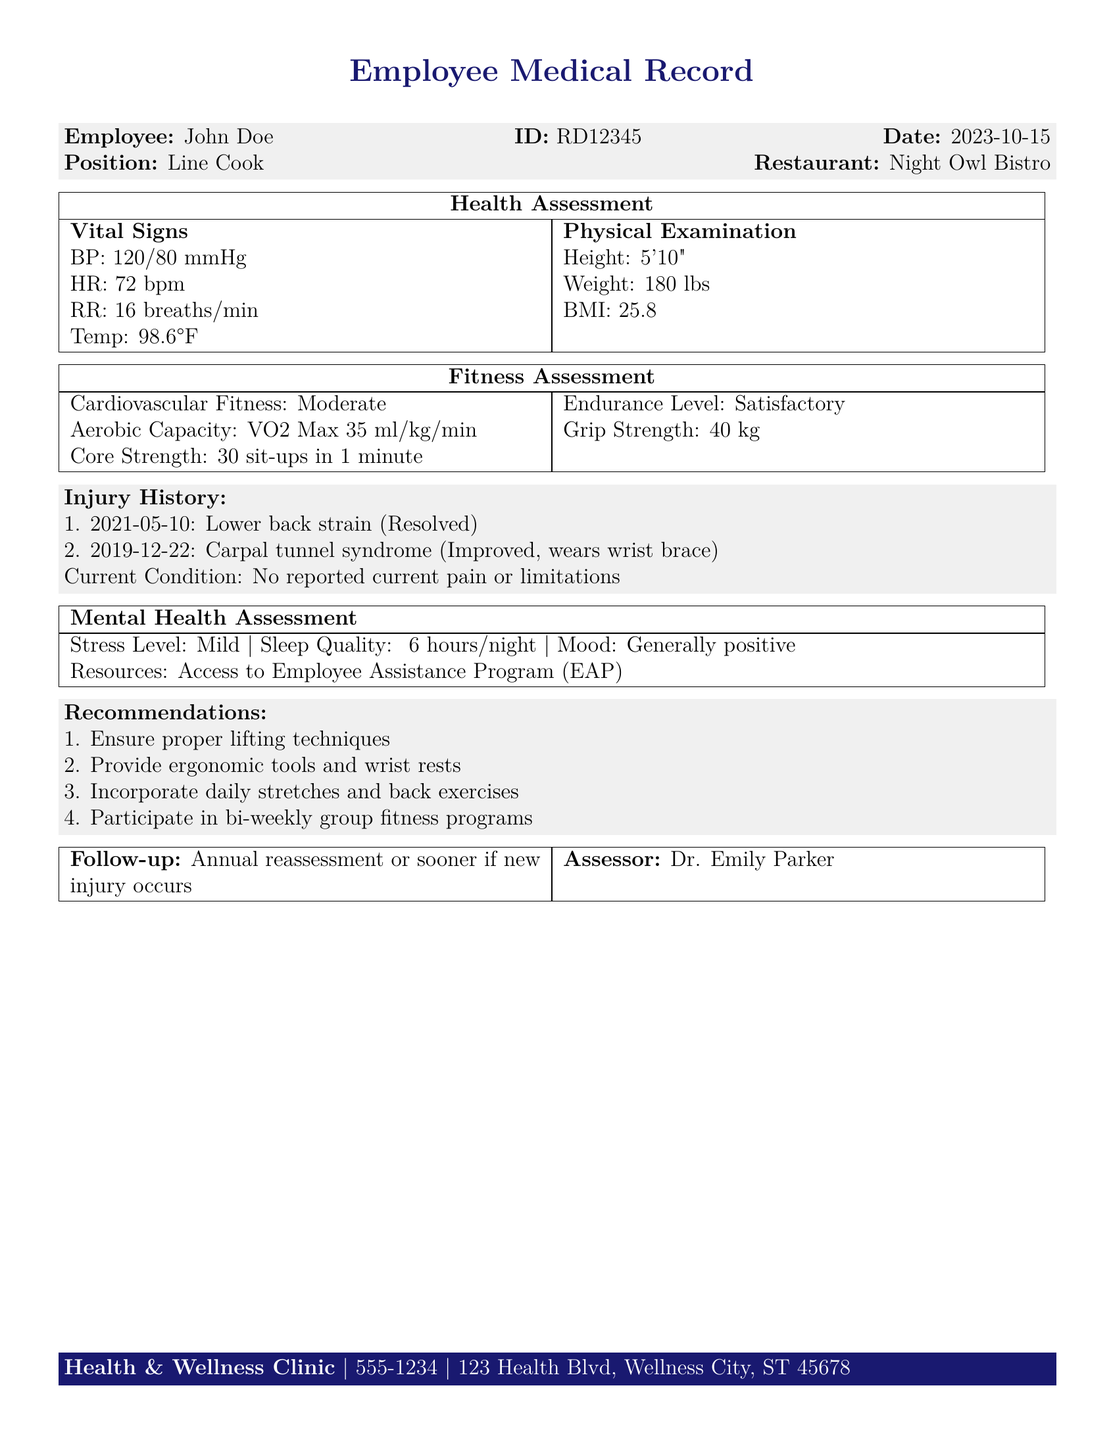what is the employee's name? The employee's name is listed at the top of the medical record.
Answer: John Doe what is the employee's ID? The employee's ID is noted in the document.
Answer: RD12345 what was the date of the health assessment? The date is specified in the medical record details.
Answer: 2023-10-15 what is the employee's position? The position is indicated in the employee information section.
Answer: Line Cook what was the cardiovascular fitness level? The cardiovascular fitness level is mentioned in the fitness assessment.
Answer: Moderate what is the grip strength measurement? The grip strength is recorded in the fitness assessment section.
Answer: 40 kg how many sit-ups can the employee do in one minute? This information is provided under the fitness assessment.
Answer: 30 sit-ups what was the most recent work-related injury? The date and details of the most recent injury are listed.
Answer: Lower back strain (Resolved) what are the recommendations related to lifting? The recommendations section lists specific suggestions regarding lifting techniques.
Answer: Ensure proper lifting techniques what is the stress level reported by the employee? The stress level is found in the mental health assessment section.
Answer: Mild 